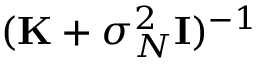Convert formula to latex. <formula><loc_0><loc_0><loc_500><loc_500>( K + \sigma _ { N } ^ { 2 } { I } ) ^ { - 1 }</formula> 